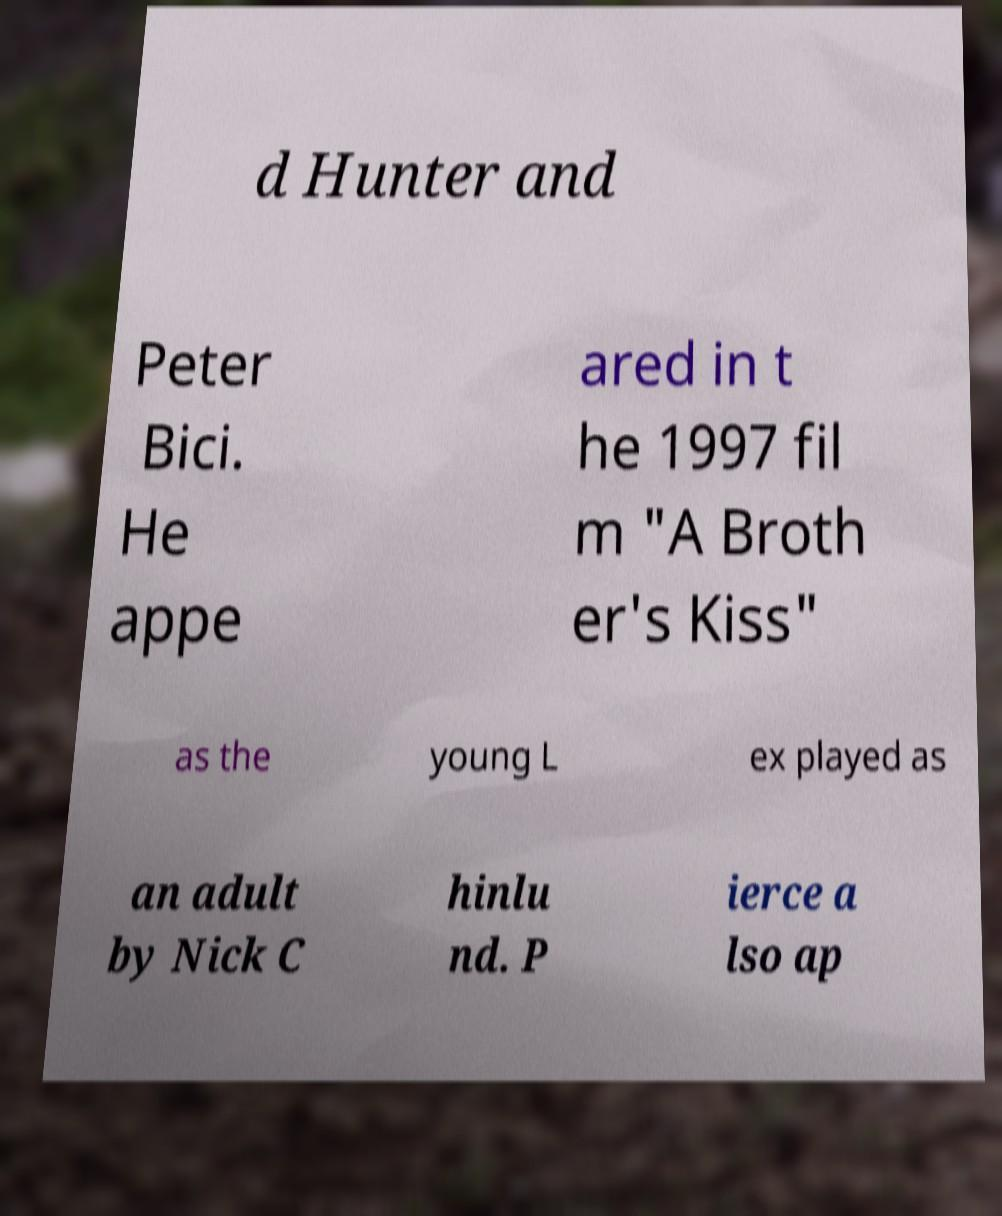Could you assist in decoding the text presented in this image and type it out clearly? d Hunter and Peter Bici. He appe ared in t he 1997 fil m "A Broth er's Kiss" as the young L ex played as an adult by Nick C hinlu nd. P ierce a lso ap 